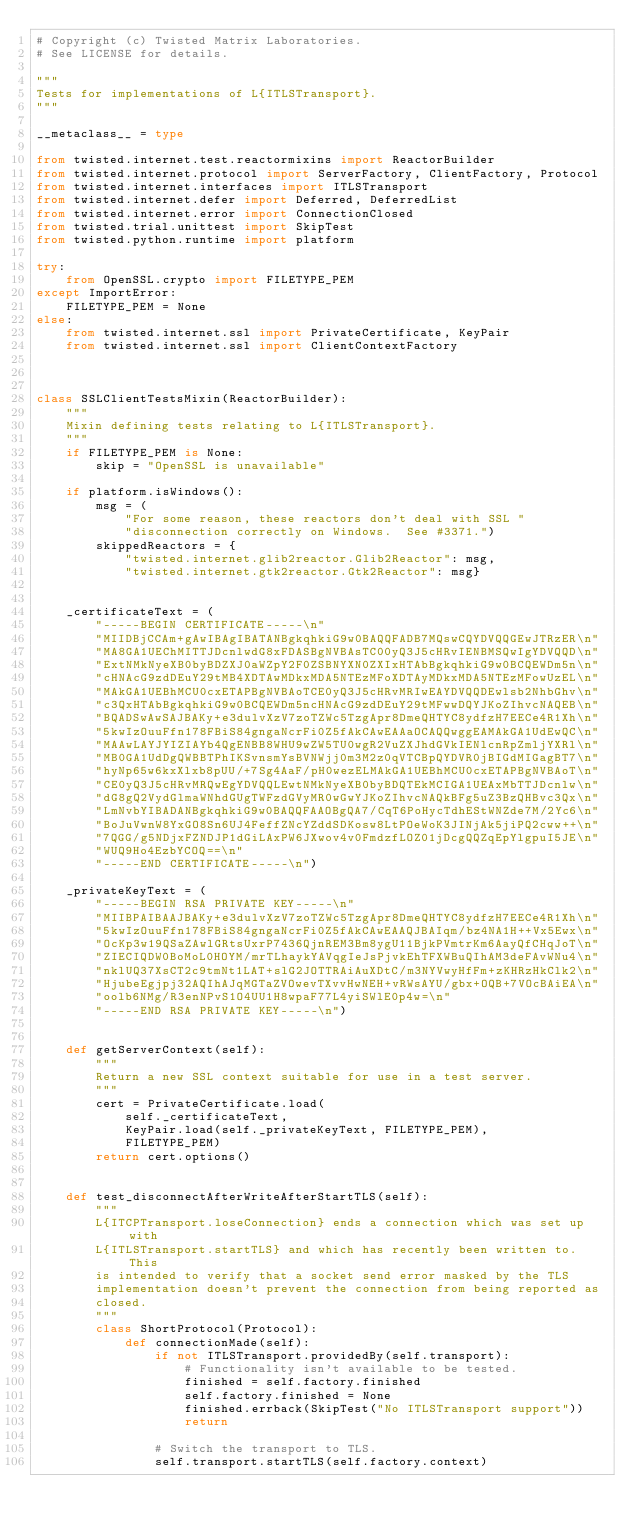<code> <loc_0><loc_0><loc_500><loc_500><_Python_># Copyright (c) Twisted Matrix Laboratories.
# See LICENSE for details.

"""
Tests for implementations of L{ITLSTransport}.
"""

__metaclass__ = type

from twisted.internet.test.reactormixins import ReactorBuilder
from twisted.internet.protocol import ServerFactory, ClientFactory, Protocol
from twisted.internet.interfaces import ITLSTransport
from twisted.internet.defer import Deferred, DeferredList
from twisted.internet.error import ConnectionClosed
from twisted.trial.unittest import SkipTest
from twisted.python.runtime import platform

try:
    from OpenSSL.crypto import FILETYPE_PEM
except ImportError:
    FILETYPE_PEM = None
else:
    from twisted.internet.ssl import PrivateCertificate, KeyPair
    from twisted.internet.ssl import ClientContextFactory



class SSLClientTestsMixin(ReactorBuilder):
    """
    Mixin defining tests relating to L{ITLSTransport}.
    """
    if FILETYPE_PEM is None:
        skip = "OpenSSL is unavailable"

    if platform.isWindows():
        msg = (
            "For some reason, these reactors don't deal with SSL "
            "disconnection correctly on Windows.  See #3371.")
        skippedReactors = {
            "twisted.internet.glib2reactor.Glib2Reactor": msg,
            "twisted.internet.gtk2reactor.Gtk2Reactor": msg}


    _certificateText = (
        "-----BEGIN CERTIFICATE-----\n"
        "MIIDBjCCAm+gAwIBAgIBATANBgkqhkiG9w0BAQQFADB7MQswCQYDVQQGEwJTRzER\n"
        "MA8GA1UEChMITTJDcnlwdG8xFDASBgNVBAsTC00yQ3J5cHRvIENBMSQwIgYDVQQD\n"
        "ExtNMkNyeXB0byBDZXJ0aWZpY2F0ZSBNYXN0ZXIxHTAbBgkqhkiG9w0BCQEWDm5n\n"
        "cHNAcG9zdDEuY29tMB4XDTAwMDkxMDA5NTEzMFoXDTAyMDkxMDA5NTEzMFowUzEL\n"
        "MAkGA1UEBhMCU0cxETAPBgNVBAoTCE0yQ3J5cHRvMRIwEAYDVQQDEwlsb2NhbGhv\n"
        "c3QxHTAbBgkqhkiG9w0BCQEWDm5ncHNAcG9zdDEuY29tMFwwDQYJKoZIhvcNAQEB\n"
        "BQADSwAwSAJBAKy+e3dulvXzV7zoTZWc5TzgApr8DmeQHTYC8ydfzH7EECe4R1Xh\n"
        "5kwIzOuuFfn178FBiS84gngaNcrFi0Z5fAkCAwEAAaOCAQQwggEAMAkGA1UdEwQC\n"
        "MAAwLAYJYIZIAYb4QgENBB8WHU9wZW5TU0wgR2VuZXJhdGVkIENlcnRpZmljYXRl\n"
        "MB0GA1UdDgQWBBTPhIKSvnsmYsBVNWjj0m3M2z0qVTCBpQYDVR0jBIGdMIGagBT7\n"
        "hyNp65w6kxXlxb8pUU/+7Sg4AaF/pH0wezELMAkGA1UEBhMCU0cxETAPBgNVBAoT\n"
        "CE0yQ3J5cHRvMRQwEgYDVQQLEwtNMkNyeXB0byBDQTEkMCIGA1UEAxMbTTJDcnlw\n"
        "dG8gQ2VydGlmaWNhdGUgTWFzdGVyMR0wGwYJKoZIhvcNAQkBFg5uZ3BzQHBvc3Qx\n"
        "LmNvbYIBADANBgkqhkiG9w0BAQQFAAOBgQA7/CqT6PoHycTdhEStWNZde7M/2Yc6\n"
        "BoJuVwnW8YxGO8Sn6UJ4FeffZNcYZddSDKosw8LtPOeWoK3JINjAk5jiPQ2cww++\n"
        "7QGG/g5NDjxFZNDJP1dGiLAxPW6JXwov4v0FmdzfLOZ01jDcgQQZqEpYlgpuI5JE\n"
        "WUQ9Ho4EzbYCOQ==\n"
        "-----END CERTIFICATE-----\n")

    _privateKeyText = (
        "-----BEGIN RSA PRIVATE KEY-----\n"
        "MIIBPAIBAAJBAKy+e3dulvXzV7zoTZWc5TzgApr8DmeQHTYC8ydfzH7EECe4R1Xh\n"
        "5kwIzOuuFfn178FBiS84gngaNcrFi0Z5fAkCAwEAAQJBAIqm/bz4NA1H++Vx5Ewx\n"
        "OcKp3w19QSaZAwlGRtsUxrP7436QjnREM3Bm8ygU11BjkPVmtrKm6AayQfCHqJoT\n"
        "ZIECIQDW0BoMoL0HOYM/mrTLhaykYAVqgIeJsPjvkEhTFXWBuQIhAM3deFAvWNu4\n"
        "nklUQ37XsCT2c9tmNt1LAT+slG2JOTTRAiAuXDtC/m3NYVwyHfFm+zKHRzHkClk2\n"
        "HjubeEgjpj32AQIhAJqMGTaZVOwevTXvvHwNEH+vRWsAYU/gbx+OQB+7VOcBAiEA\n"
        "oolb6NMg/R3enNPvS1O4UU1H8wpaF77L4yiSWlE0p4w=\n"
        "-----END RSA PRIVATE KEY-----\n")


    def getServerContext(self):
        """
        Return a new SSL context suitable for use in a test server.
        """
        cert = PrivateCertificate.load(
            self._certificateText,
            KeyPair.load(self._privateKeyText, FILETYPE_PEM),
            FILETYPE_PEM)
        return cert.options()


    def test_disconnectAfterWriteAfterStartTLS(self):
        """
        L{ITCPTransport.loseConnection} ends a connection which was set up with
        L{ITLSTransport.startTLS} and which has recently been written to.  This
        is intended to verify that a socket send error masked by the TLS
        implementation doesn't prevent the connection from being reported as
        closed.
        """
        class ShortProtocol(Protocol):
            def connectionMade(self):
                if not ITLSTransport.providedBy(self.transport):
                    # Functionality isn't available to be tested.
                    finished = self.factory.finished
                    self.factory.finished = None
                    finished.errback(SkipTest("No ITLSTransport support"))
                    return

                # Switch the transport to TLS.
                self.transport.startTLS(self.factory.context)</code> 